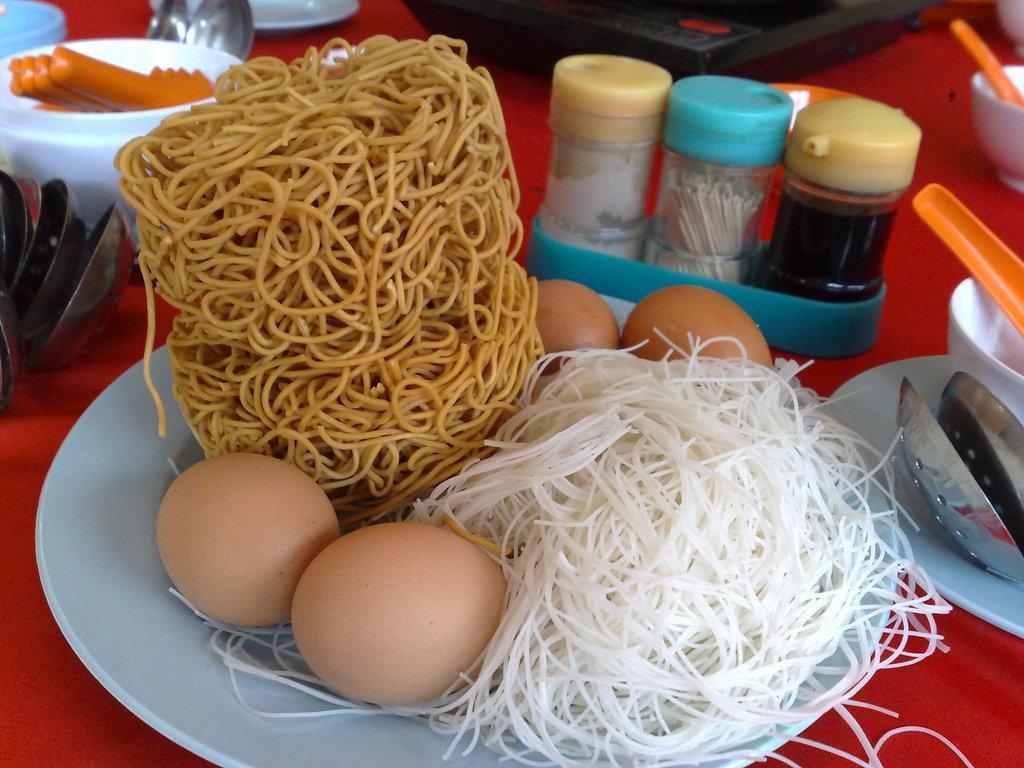How would you summarize this image in a sentence or two? In this image I can see few food items in the plate and the food items are in white, brown and cream color and the plate is in white color and I can see few bottles, spoons and few objects on the red color surface. 